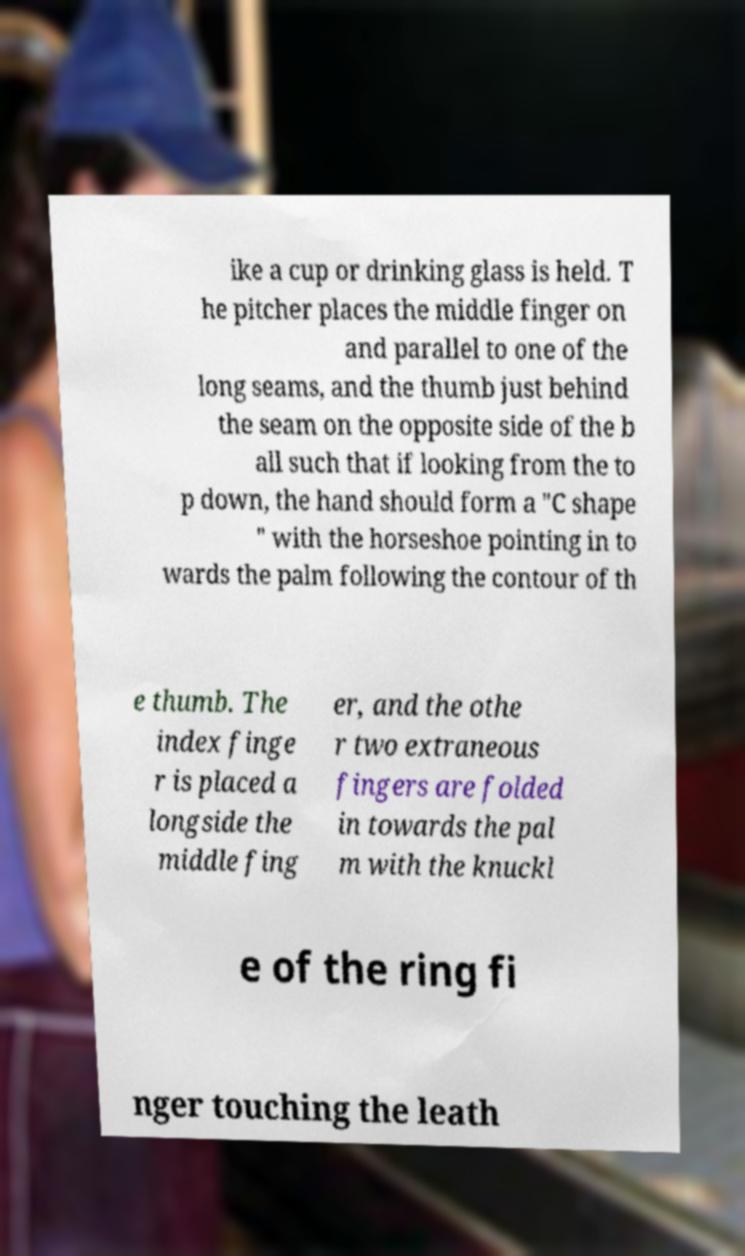What messages or text are displayed in this image? I need them in a readable, typed format. ike a cup or drinking glass is held. T he pitcher places the middle finger on and parallel to one of the long seams, and the thumb just behind the seam on the opposite side of the b all such that if looking from the to p down, the hand should form a "C shape " with the horseshoe pointing in to wards the palm following the contour of th e thumb. The index finge r is placed a longside the middle fing er, and the othe r two extraneous fingers are folded in towards the pal m with the knuckl e of the ring fi nger touching the leath 